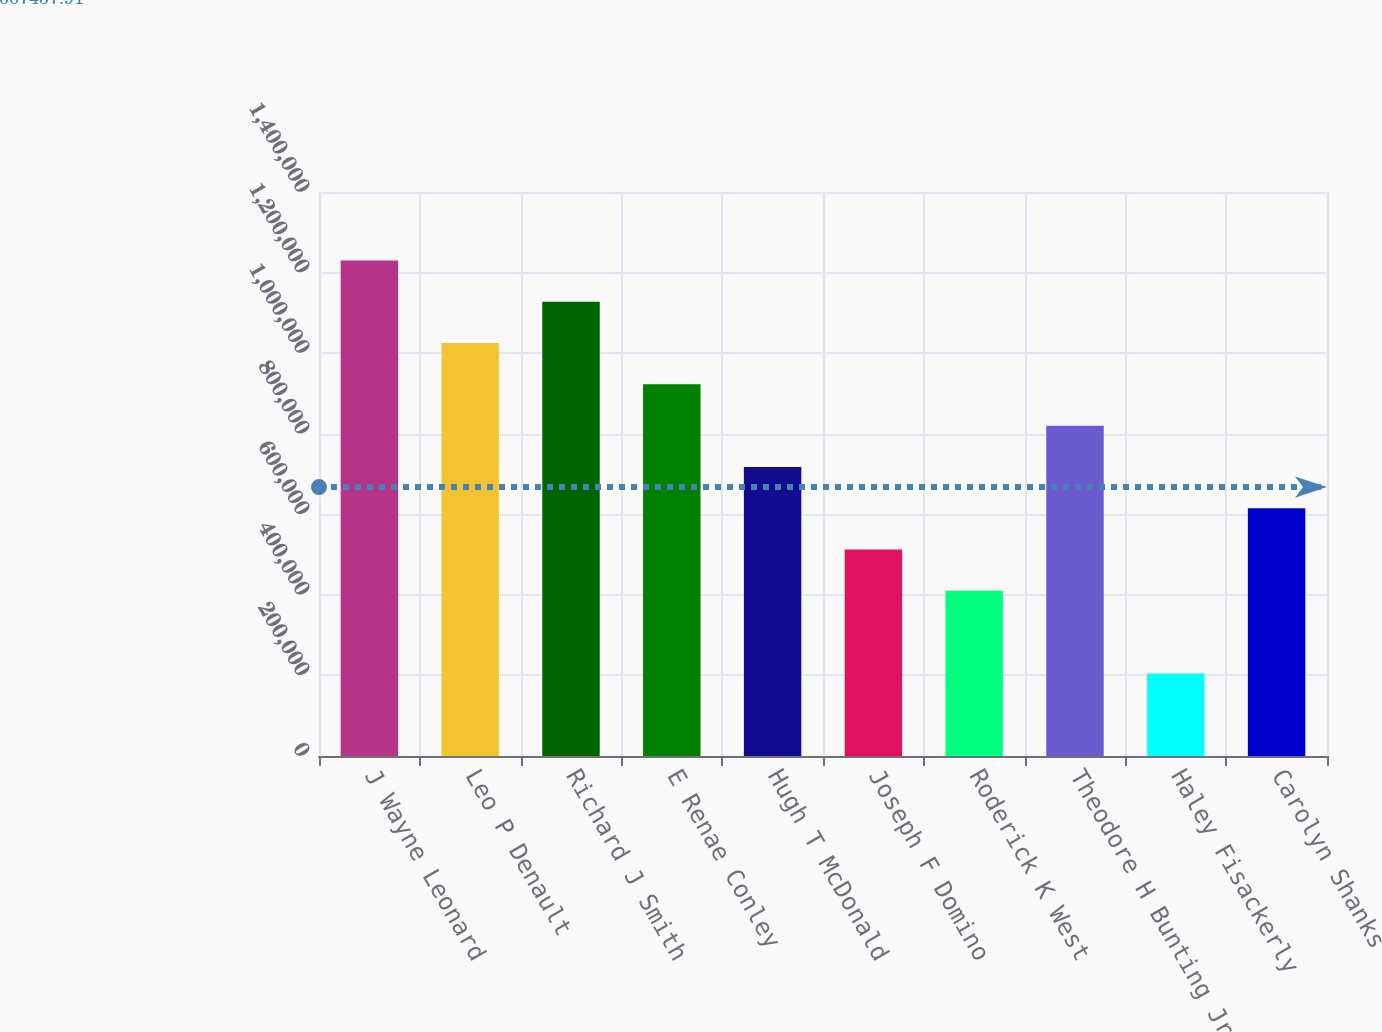Convert chart to OTSL. <chart><loc_0><loc_0><loc_500><loc_500><bar_chart><fcel>J Wayne Leonard<fcel>Leo P Denault<fcel>Richard J Smith<fcel>E Renae Conley<fcel>Hugh T McDonald<fcel>Joseph F Domino<fcel>Roderick K West<fcel>Theodore H Bunting Jr<fcel>Haley Fisackerly<fcel>Carolyn Shanks<nl><fcel>1.23e+06<fcel>1.025e+06<fcel>1.1275e+06<fcel>922501<fcel>717502<fcel>512503<fcel>410003<fcel>820002<fcel>205004<fcel>615002<nl></chart> 